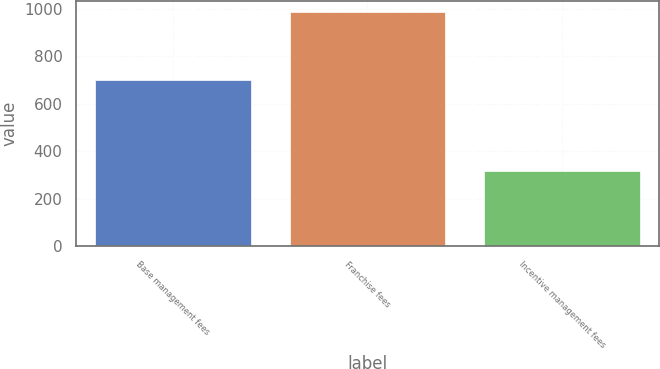Convert chart to OTSL. <chart><loc_0><loc_0><loc_500><loc_500><bar_chart><fcel>Base management fees<fcel>Franchise fees<fcel>Incentive management fees<nl><fcel>698<fcel>984<fcel>319<nl></chart> 